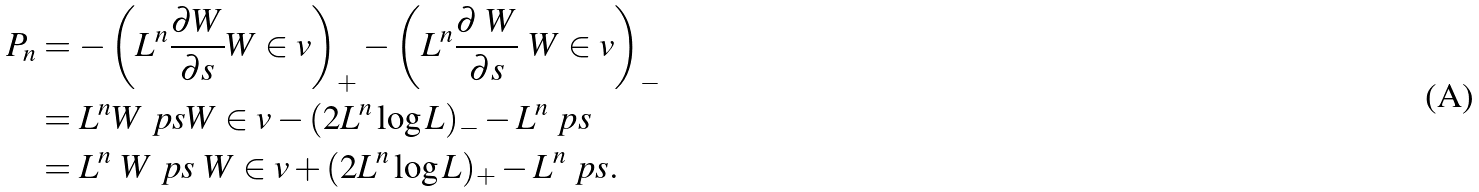<formula> <loc_0><loc_0><loc_500><loc_500>P _ { n } & = - \left ( L ^ { n } \frac { \partial W } { \partial s } W \in v \right ) _ { + } - \left ( L ^ { n } \frac { \partial \ W } { \partial s } \ W \in v \right ) _ { - } \\ & = L ^ { n } W \ p { s } W \in v - ( 2 L ^ { n } \log L ) _ { - } - L ^ { n } \ p { s } \\ & = L ^ { n } \ W \ p { s } \ W \in v + ( 2 L ^ { n } \log L ) _ { + } - L ^ { n } \ p { s } .</formula> 